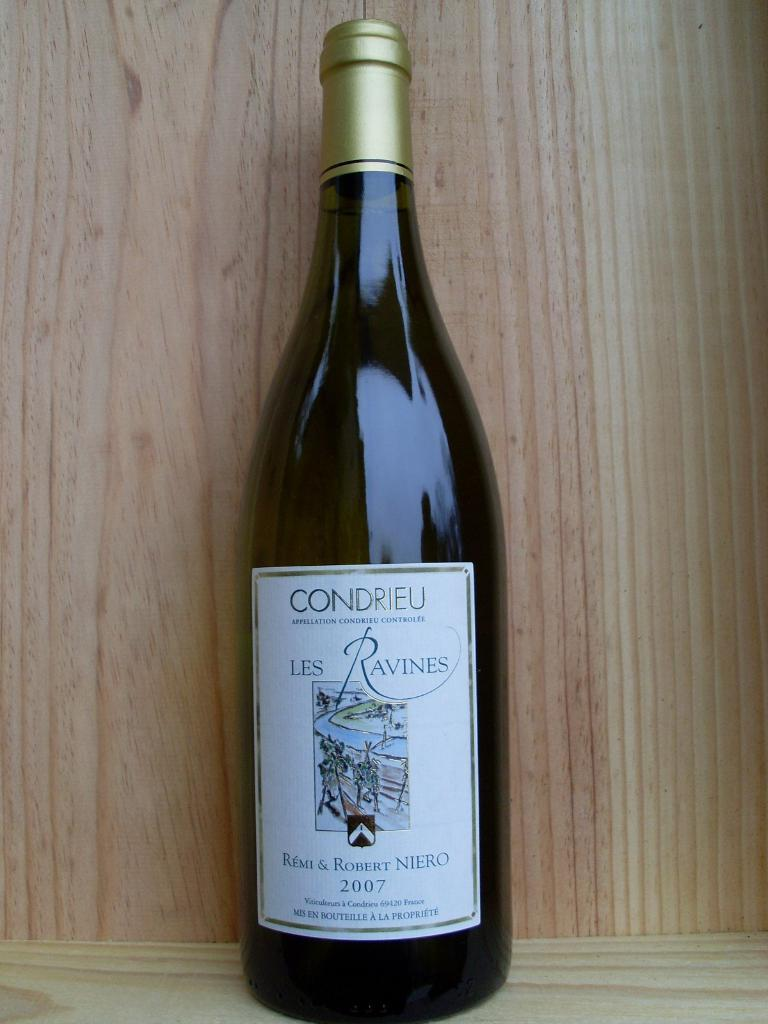<image>
Write a terse but informative summary of the picture. A bottle of Condrieu Les Ravines wine from 2007. 